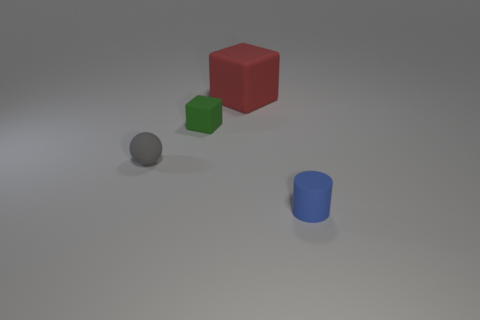Subtract 1 blocks. How many blocks are left? 1 Add 1 blue objects. How many objects exist? 5 Subtract all cyan spheres. Subtract all red cylinders. How many spheres are left? 1 Subtract all spheres. How many objects are left? 3 Subtract all blue spheres. How many red blocks are left? 1 Subtract all big red rubber cubes. Subtract all small cyan blocks. How many objects are left? 3 Add 4 gray balls. How many gray balls are left? 5 Add 3 large things. How many large things exist? 4 Subtract 0 green cylinders. How many objects are left? 4 